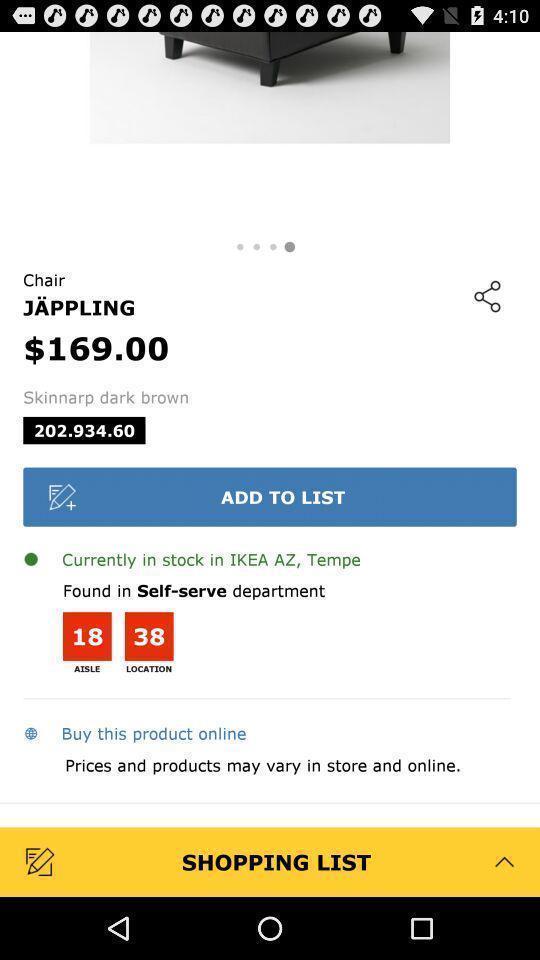Please provide a description for this image. Screen shows a products details in shopping application. 